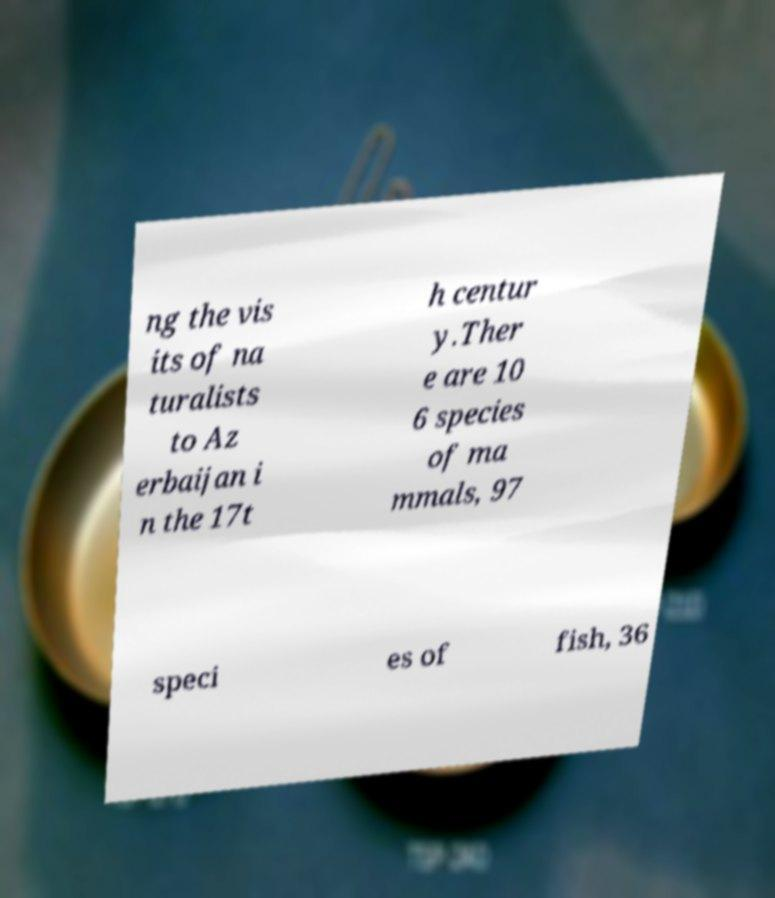Please identify and transcribe the text found in this image. ng the vis its of na turalists to Az erbaijan i n the 17t h centur y.Ther e are 10 6 species of ma mmals, 97 speci es of fish, 36 